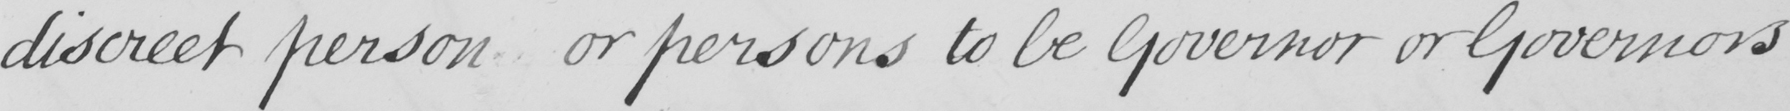What is written in this line of handwriting? discreet person or persons to be Governor or Governors 